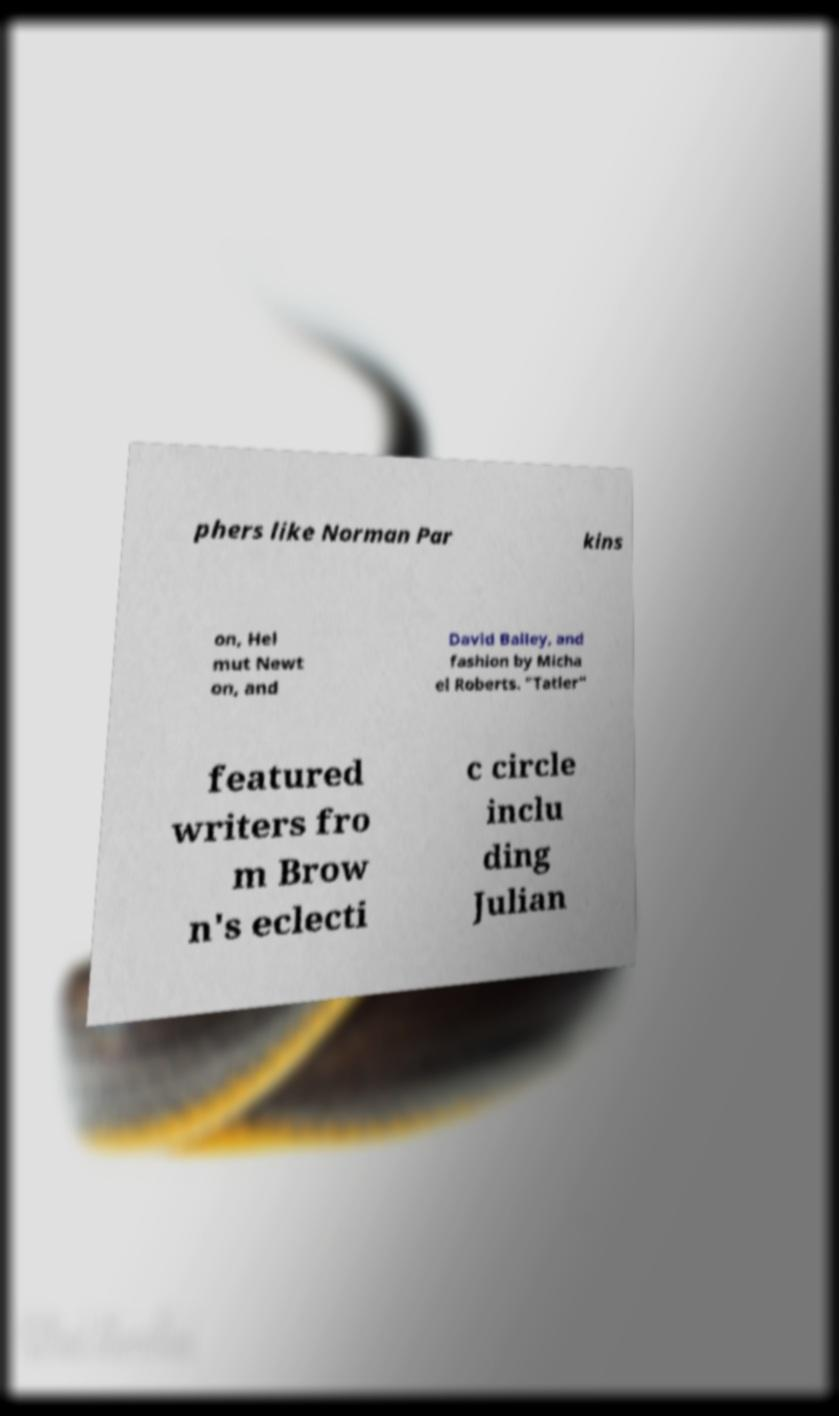What messages or text are displayed in this image? I need them in a readable, typed format. phers like Norman Par kins on, Hel mut Newt on, and David Bailey, and fashion by Micha el Roberts. "Tatler" featured writers fro m Brow n's eclecti c circle inclu ding Julian 